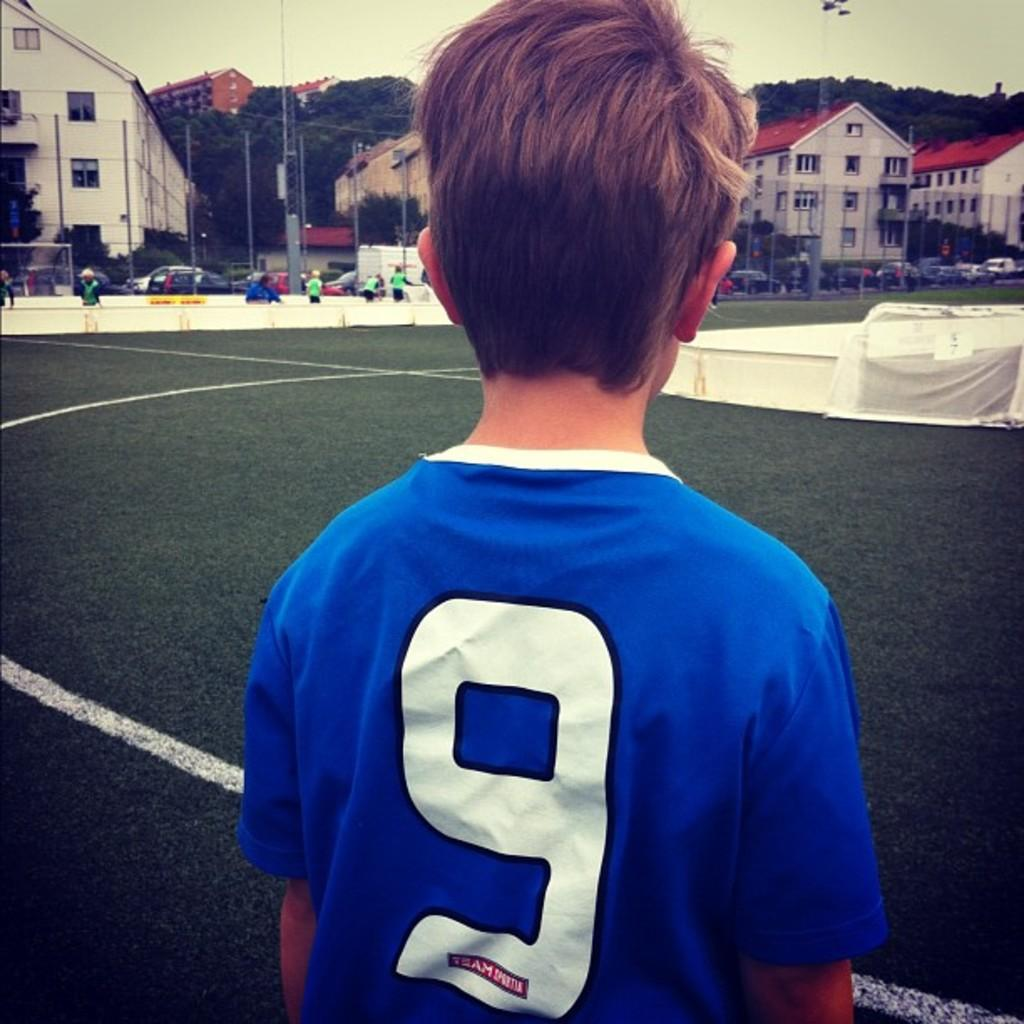<image>
Share a concise interpretation of the image provided. A little boy with the number 9 on the back of his shirt facing buildings with red roofs. 